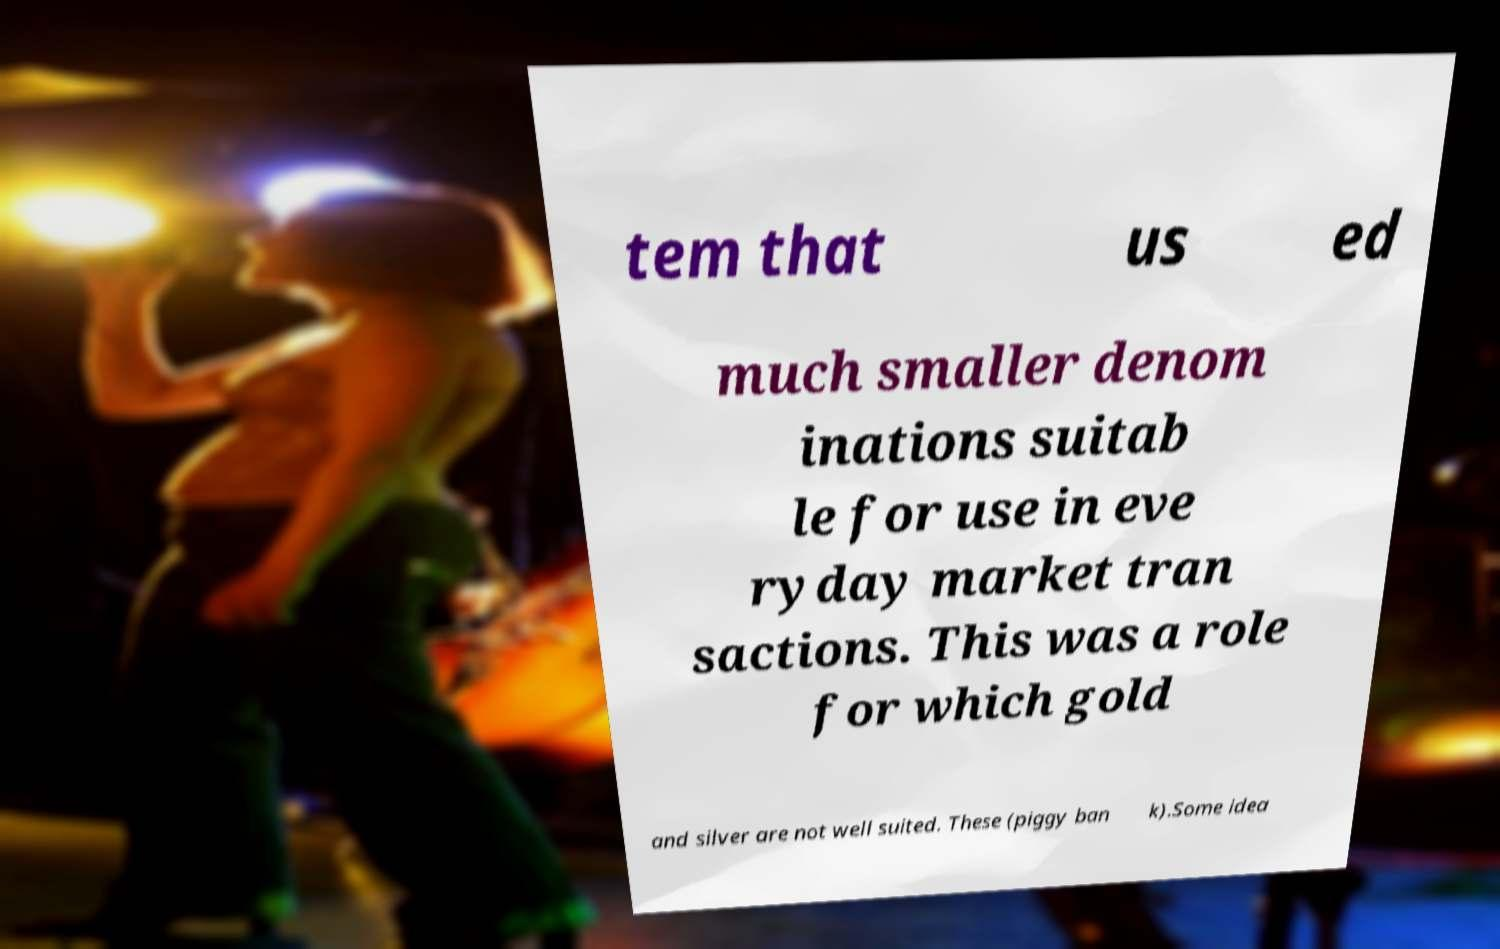Can you accurately transcribe the text from the provided image for me? tem that us ed much smaller denom inations suitab le for use in eve ryday market tran sactions. This was a role for which gold and silver are not well suited. These (piggy ban k).Some idea 